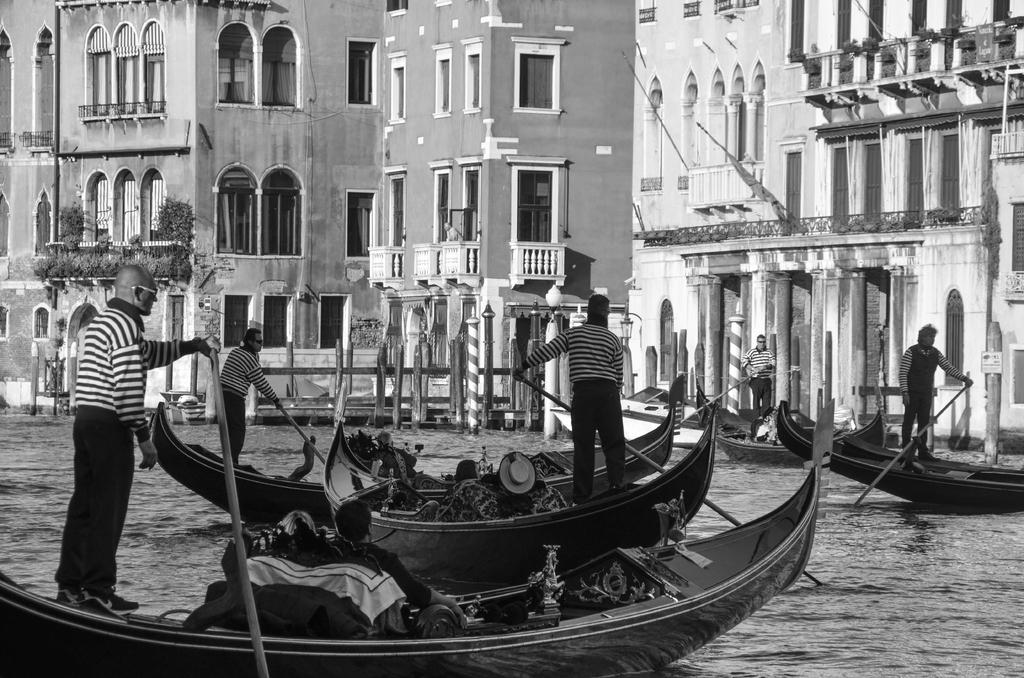What is happening on the water in the image? There are boats on the water in the image, and people are standing on the boats. What are the people on the boats holding? The people are holding paddles. What can be seen in the background of the image? There are buildings and plants in the background of the image. What type of tin can be seen on the sidewalk in the image? There is no tin or sidewalk present in the image; it features boats on the water with people holding paddles, and buildings and plants in the background. What is inside the box that is visible in the image? There is no box present in the image. 